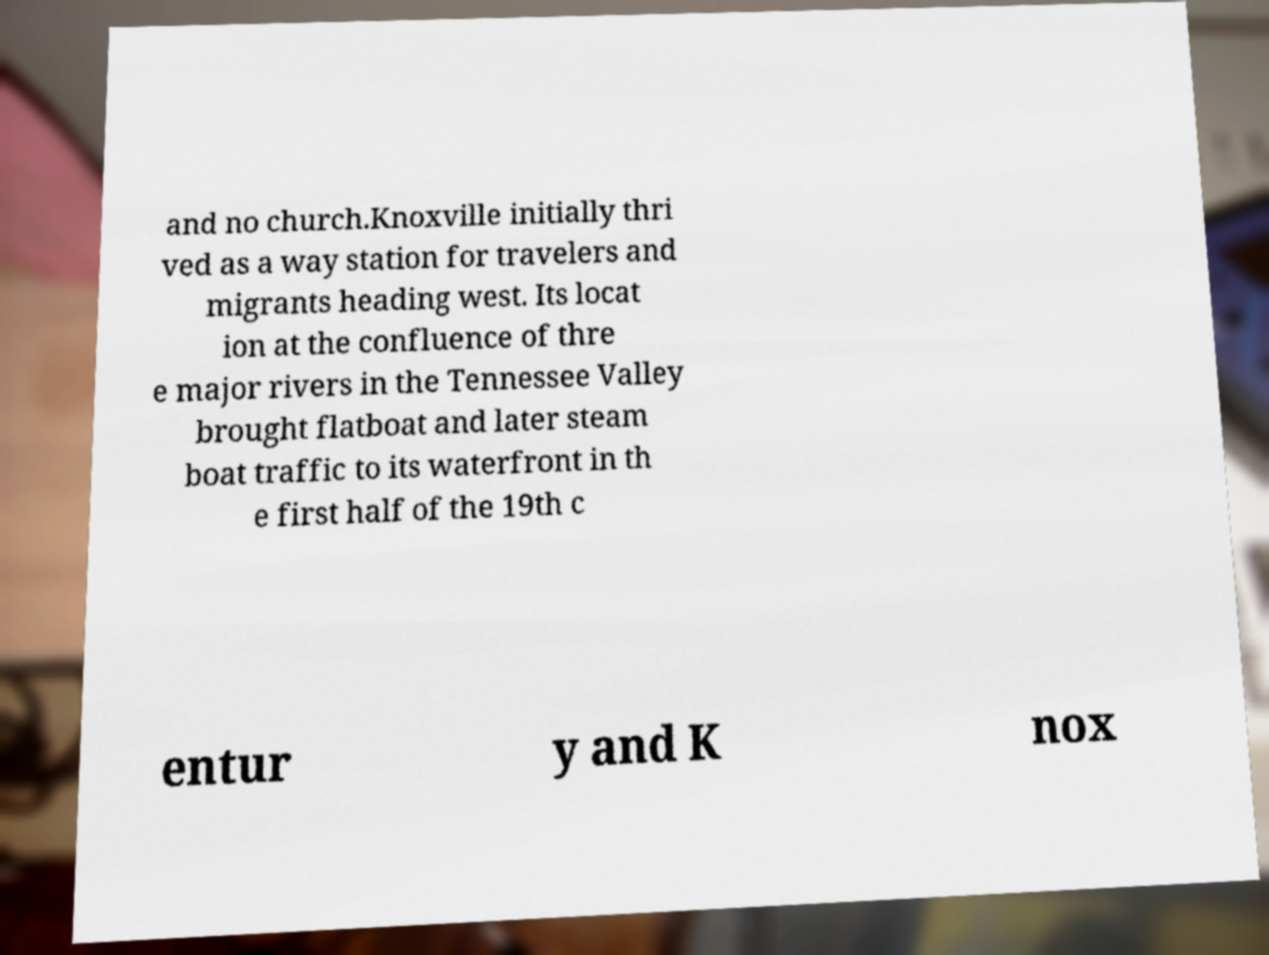There's text embedded in this image that I need extracted. Can you transcribe it verbatim? and no church.Knoxville initially thri ved as a way station for travelers and migrants heading west. Its locat ion at the confluence of thre e major rivers in the Tennessee Valley brought flatboat and later steam boat traffic to its waterfront in th e first half of the 19th c entur y and K nox 